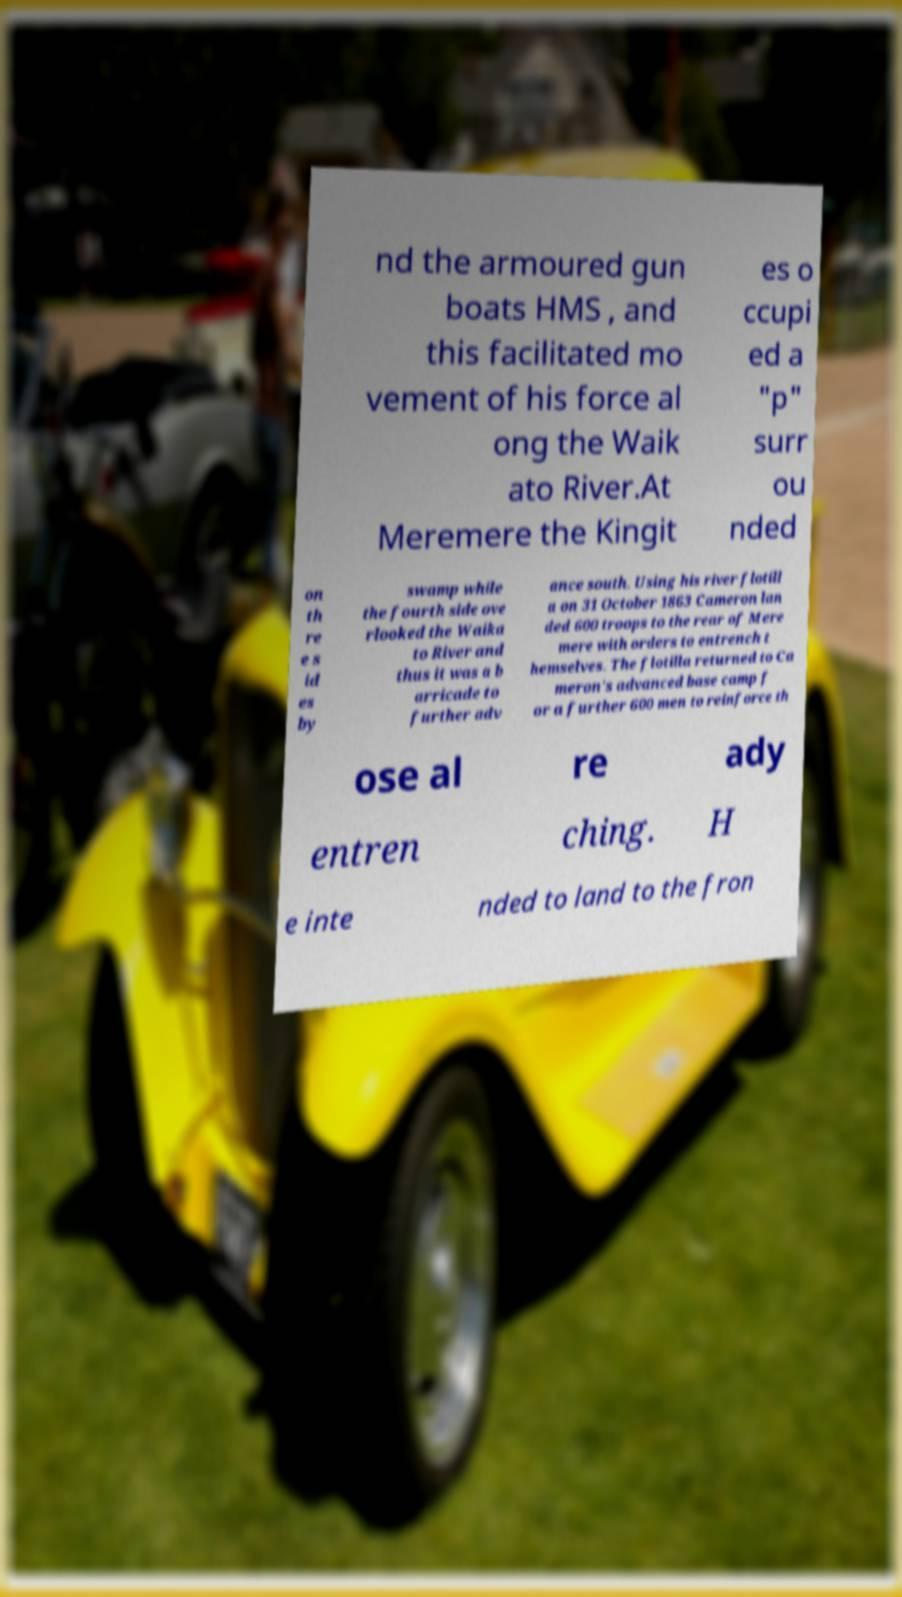I need the written content from this picture converted into text. Can you do that? nd the armoured gun boats HMS , and this facilitated mo vement of his force al ong the Waik ato River.At Meremere the Kingit es o ccupi ed a "p" surr ou nded on th re e s id es by swamp while the fourth side ove rlooked the Waika to River and thus it was a b arricade to further adv ance south. Using his river flotill a on 31 October 1863 Cameron lan ded 600 troops to the rear of Mere mere with orders to entrench t hemselves. The flotilla returned to Ca meron's advanced base camp f or a further 600 men to reinforce th ose al re ady entren ching. H e inte nded to land to the fron 